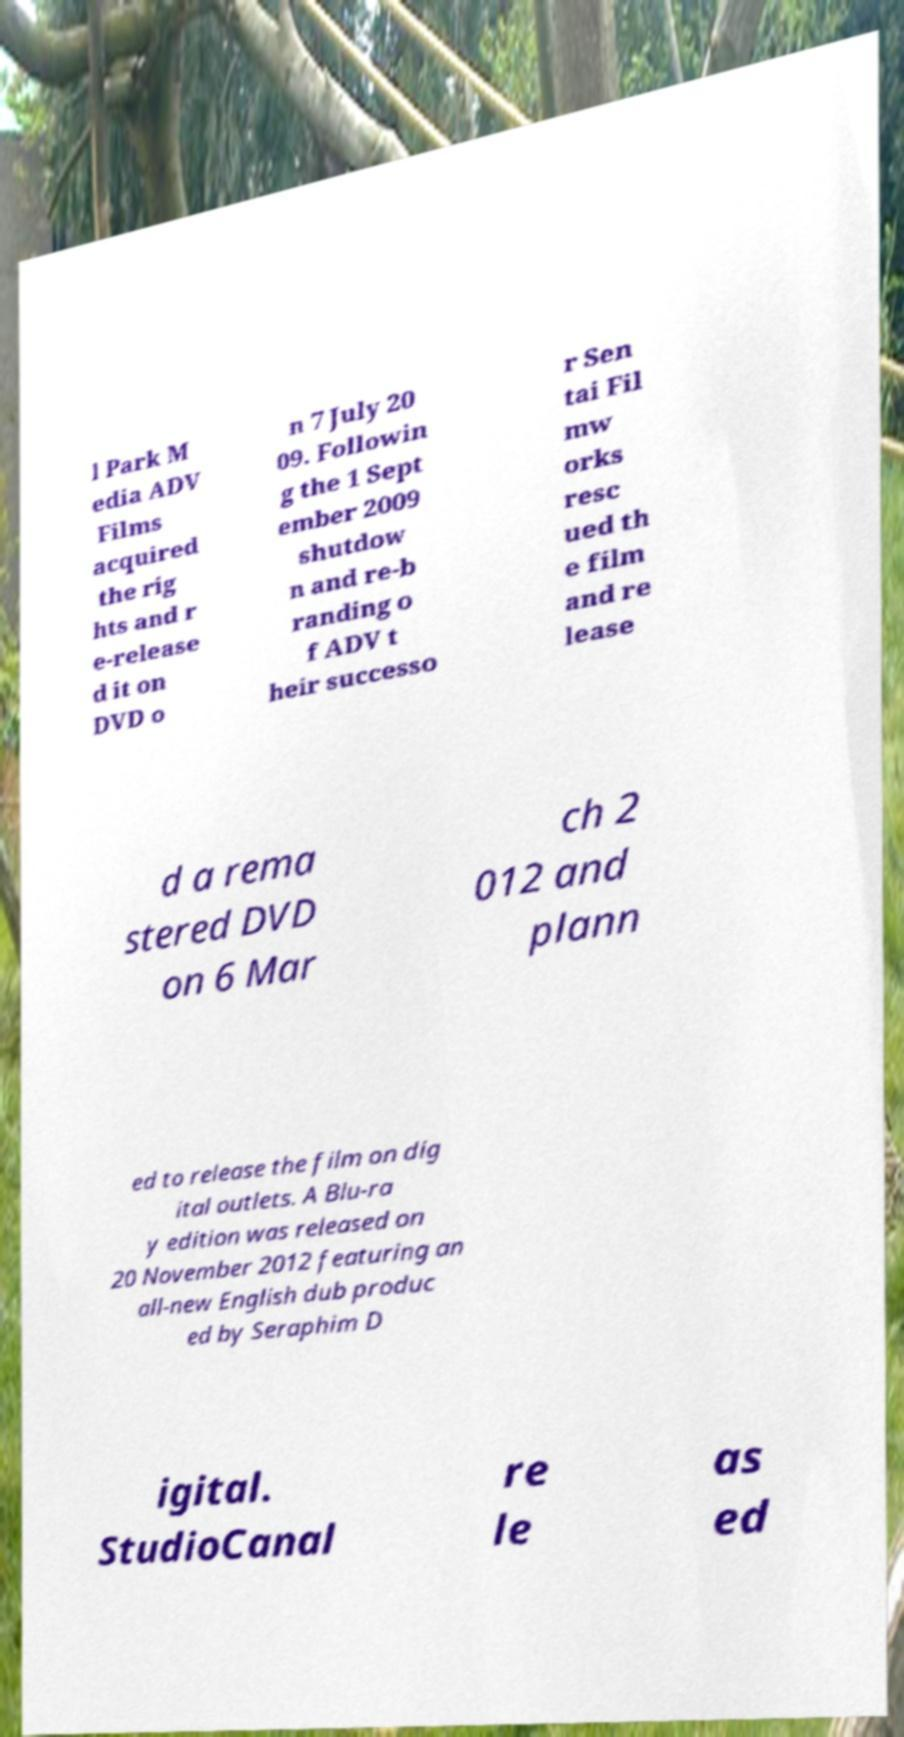Please identify and transcribe the text found in this image. l Park M edia ADV Films acquired the rig hts and r e-release d it on DVD o n 7 July 20 09. Followin g the 1 Sept ember 2009 shutdow n and re-b randing o f ADV t heir successo r Sen tai Fil mw orks resc ued th e film and re lease d a rema stered DVD on 6 Mar ch 2 012 and plann ed to release the film on dig ital outlets. A Blu-ra y edition was released on 20 November 2012 featuring an all-new English dub produc ed by Seraphim D igital. StudioCanal re le as ed 